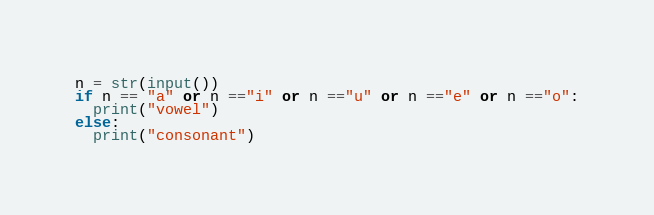Convert code to text. <code><loc_0><loc_0><loc_500><loc_500><_Python_>n = str(input())
if n == "a" or n =="i" or n =="u" or n =="e" or n =="o":
  print("vowel")
else:
  print("consonant")</code> 